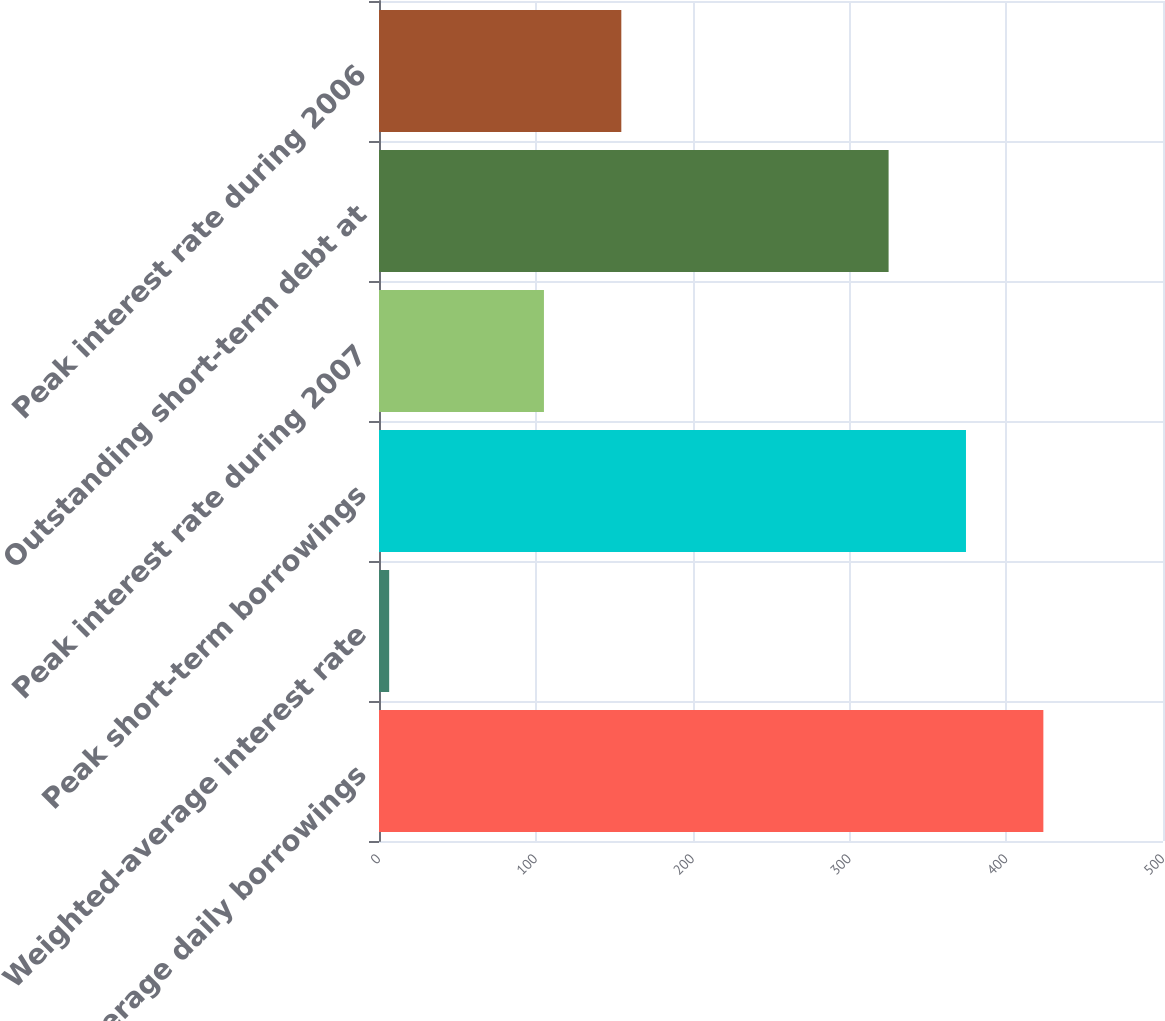Convert chart. <chart><loc_0><loc_0><loc_500><loc_500><bar_chart><fcel>Average daily borrowings<fcel>Weighted-average interest rate<fcel>Peak short-term borrowings<fcel>Peak interest rate during 2007<fcel>Outstanding short-term debt at<fcel>Peak interest rate during 2006<nl><fcel>423.7<fcel>6.49<fcel>374.35<fcel>105.19<fcel>325<fcel>154.54<nl></chart> 